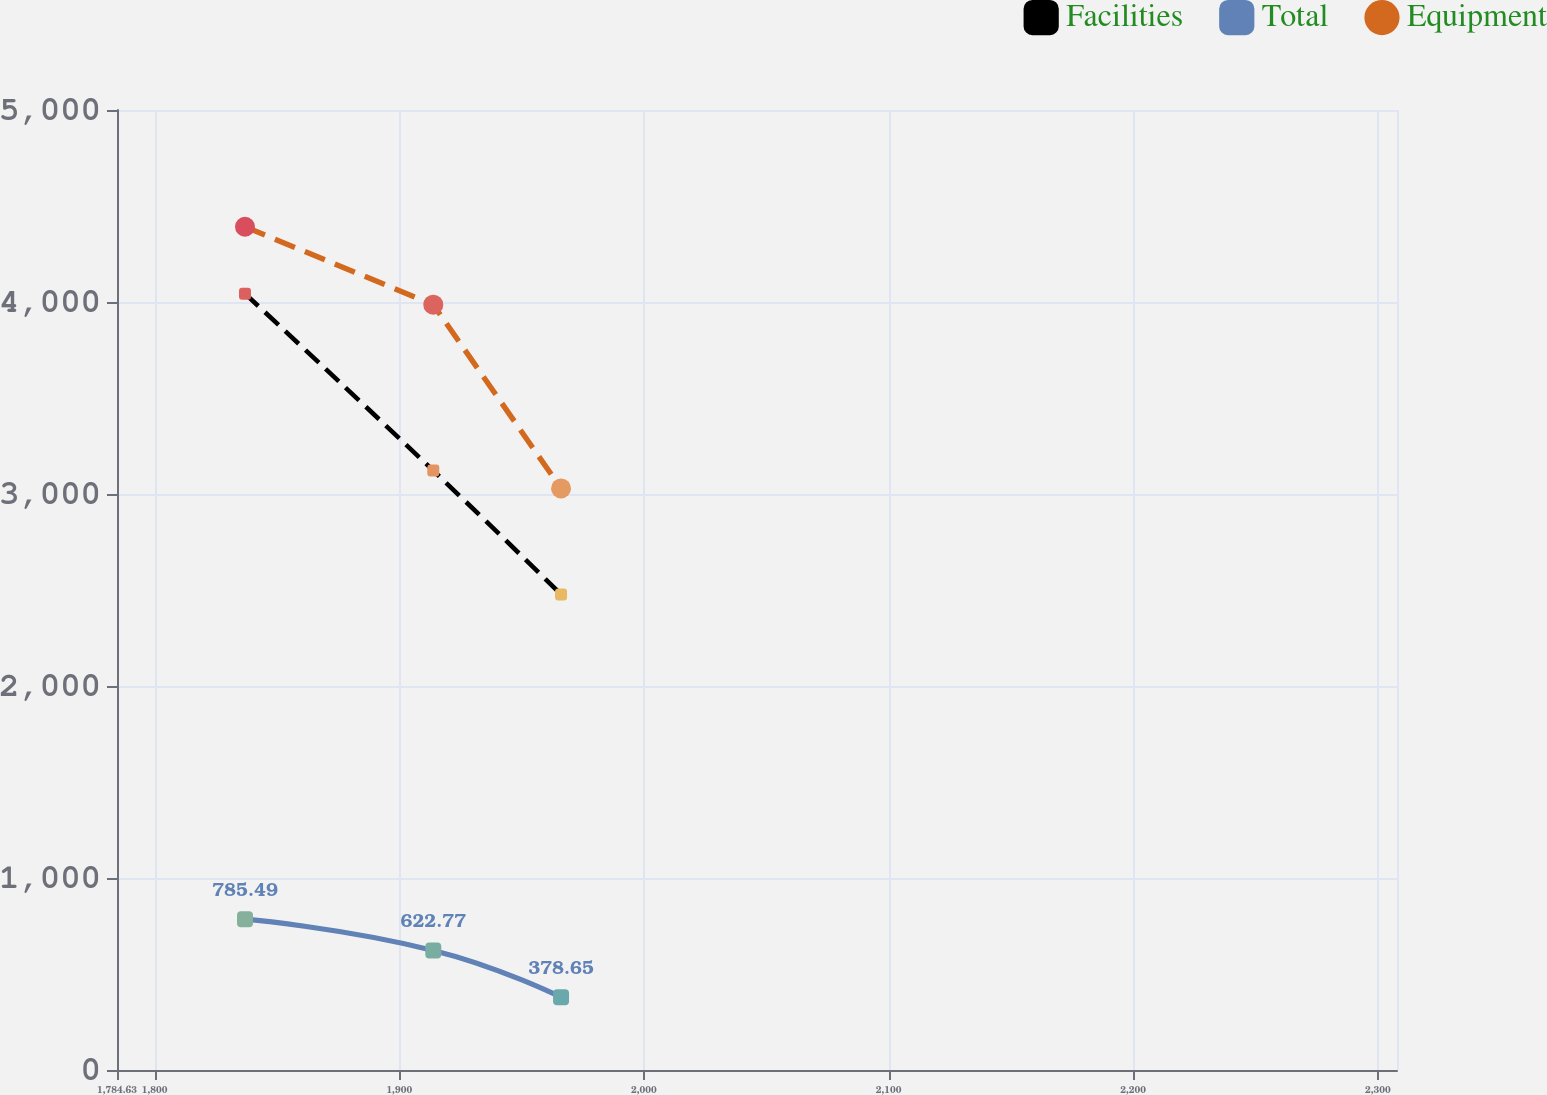<chart> <loc_0><loc_0><loc_500><loc_500><line_chart><ecel><fcel>Facilities<fcel>Total<fcel>Equipment<nl><fcel>1836.95<fcel>4043.52<fcel>785.49<fcel>4391.85<nl><fcel>1913.91<fcel>3121.79<fcel>622.77<fcel>3986.3<nl><fcel>1966.13<fcel>2476.64<fcel>378.65<fcel>3028.96<nl><fcel>2307.93<fcel>1742.96<fcel>142.32<fcel>1708.15<nl><fcel>2360.15<fcel>1444.52<fcel>27.42<fcel>1409.96<nl></chart> 